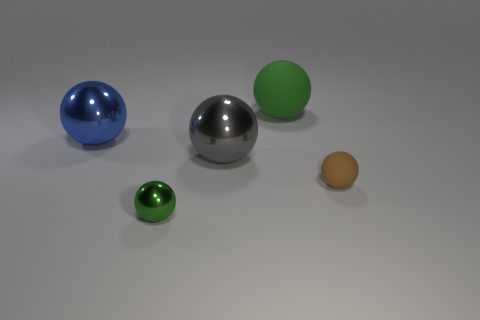Subtract all big matte balls. How many balls are left? 4 Add 3 big purple metallic cylinders. How many objects exist? 8 Subtract all gray balls. How many balls are left? 4 Subtract all blue blocks. How many green spheres are left? 2 Subtract all large blue objects. Subtract all large things. How many objects are left? 1 Add 1 small green metal things. How many small green metal things are left? 2 Add 1 cyan matte spheres. How many cyan matte spheres exist? 1 Subtract 1 gray balls. How many objects are left? 4 Subtract 4 balls. How many balls are left? 1 Subtract all blue spheres. Subtract all yellow cylinders. How many spheres are left? 4 